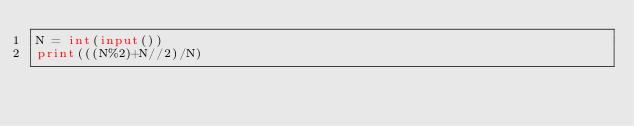Convert code to text. <code><loc_0><loc_0><loc_500><loc_500><_Python_>N = int(input())
print(((N%2)+N//2)/N)</code> 